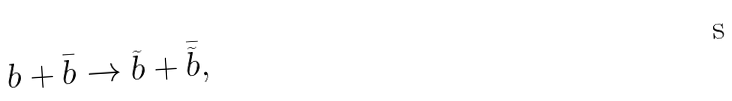Convert formula to latex. <formula><loc_0><loc_0><loc_500><loc_500>b + \bar { b } \rightarrow \widetilde { b } + \bar { \widetilde { b } } ,</formula> 